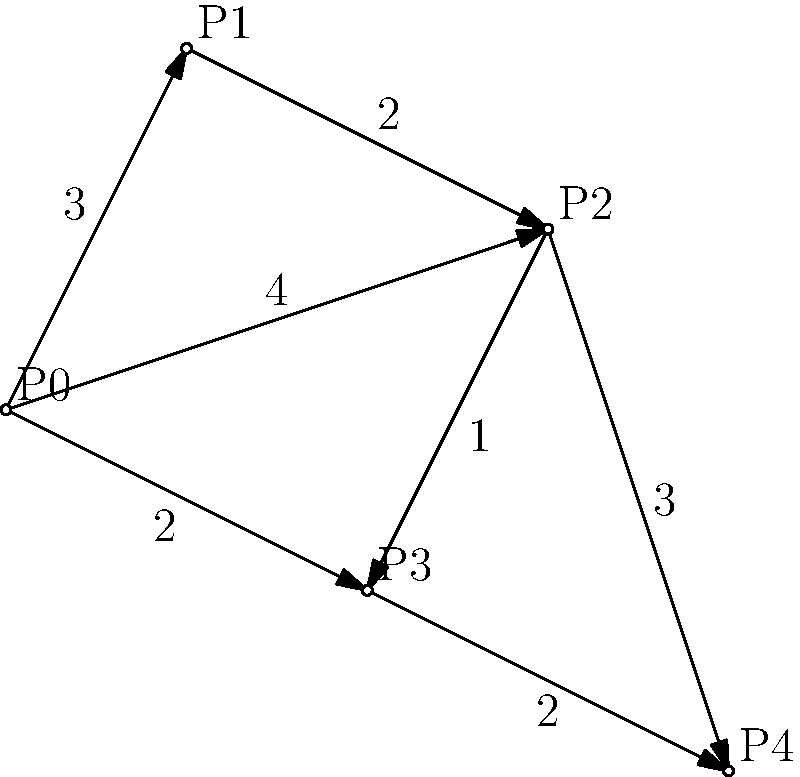As a clever lynx, you've discovered a network of prey locations in your territory. The diagram shows these locations (P0 to P4) and the time it takes to move between them. Starting from your den at P0, what's the quickest route to visit all prey locations exactly once and return home, minimizing your total travel time? Let's approach this step-by-step:

1) This is a variation of the Traveling Salesman Problem, where we need to find the shortest Hamiltonian cycle.

2) We'll use a brute force approach to check all possible routes:

   P0 → P1 → P2 → P3 → P4 → P0: 3 + 2 + 1 + 2 + 4 = 12
   P0 → P1 → P2 → P4 → P3 → P0: 3 + 2 + 3 + 2 + 2 = 12
   P0 → P2 → P1 → P3 → P4 → P0: 4 + 2 + 3 + 2 + 4 = 15
   P0 → P2 → P3 → P1 → P4 → P0: 4 + 1 + 3 + 5 + 4 = 17
   P0 → P2 → P3 → P4 → P1 → P0: 4 + 1 + 2 + 5 + 3 = 15
   P0 → P2 → P4 → P3 → P1 → P0: 4 + 3 + 2 + 3 + 3 = 15
   P0 → P3 → P2 → P1 → P4 → P0: 2 + 1 + 2 + 5 + 4 = 14
   P0 → P3 → P2 → P4 → P1 → P0: 2 + 1 + 3 + 5 + 3 = 14
   P0 → P3 → P4 → P2 → P1 → P0: 2 + 2 + 3 + 2 + 3 = 12

3) The quickest routes all take 12 units of time. There are three such routes:
   P0 → P1 → P2 → P3 → P4 → P0
   P0 → P1 → P2 → P4 → P3 → P0
   P0 → P3 → P4 → P2 → P1 → P0

4) Any of these routes would be correct, but let's choose the first one for our answer.
Answer: P0 → P1 → P2 → P3 → P4 → P0 